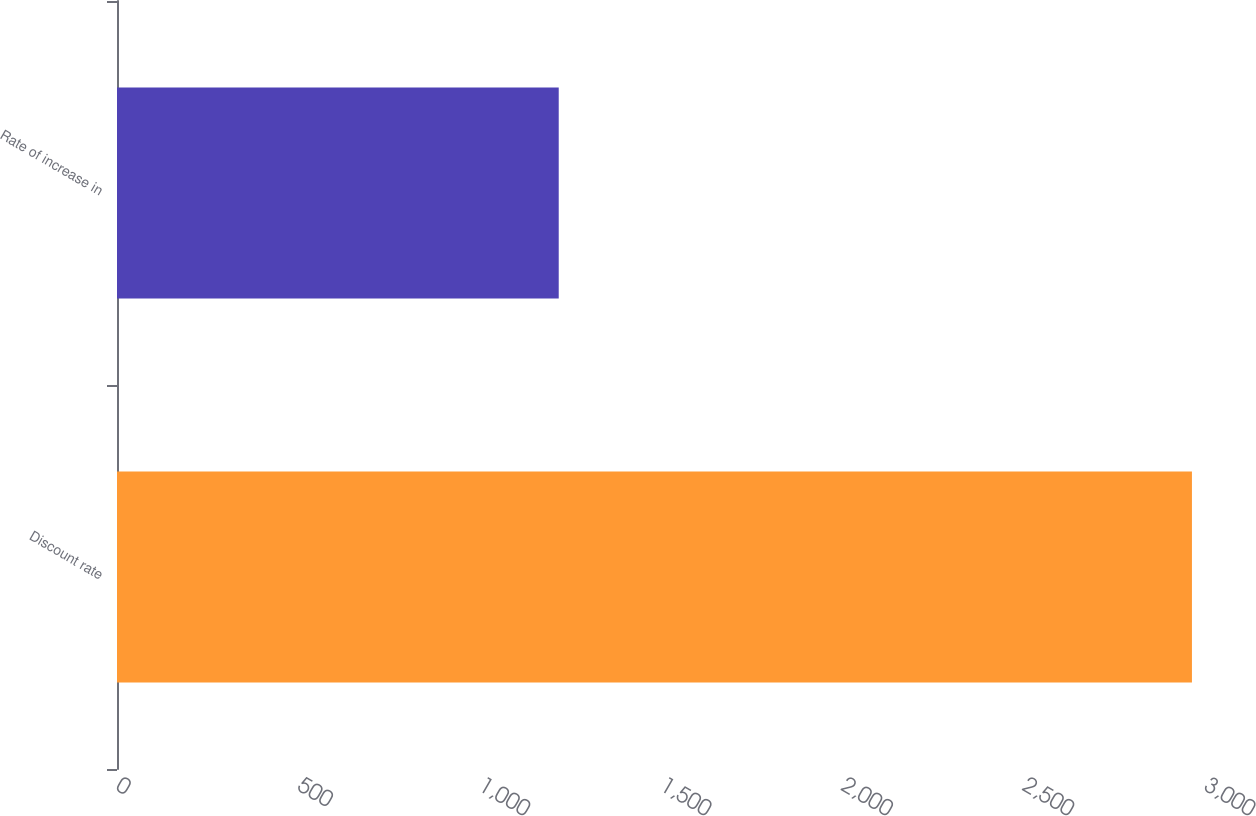Convert chart. <chart><loc_0><loc_0><loc_500><loc_500><bar_chart><fcel>Discount rate<fcel>Rate of increase in<nl><fcel>2964<fcel>1218<nl></chart> 